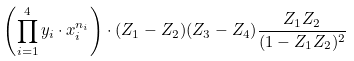<formula> <loc_0><loc_0><loc_500><loc_500>\left ( \prod _ { i = 1 } ^ { 4 } y _ { i } \cdot x _ { i } ^ { n _ { i } } \right ) \cdot ( Z _ { 1 } - Z _ { 2 } ) ( Z _ { 3 } - Z _ { 4 } ) \frac { Z _ { 1 } Z _ { 2 } } { ( 1 - Z _ { 1 } Z _ { 2 } ) ^ { 2 } }</formula> 